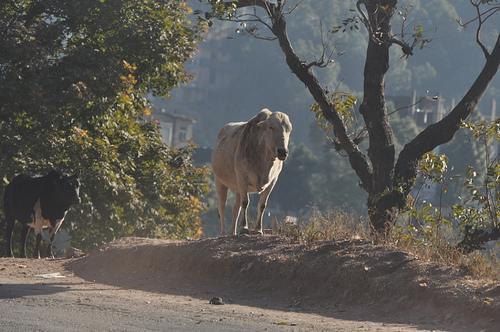How many animals are there?
Give a very brief answer. 2. How many branches does the tree trunk split into?
Give a very brief answer. 3. 